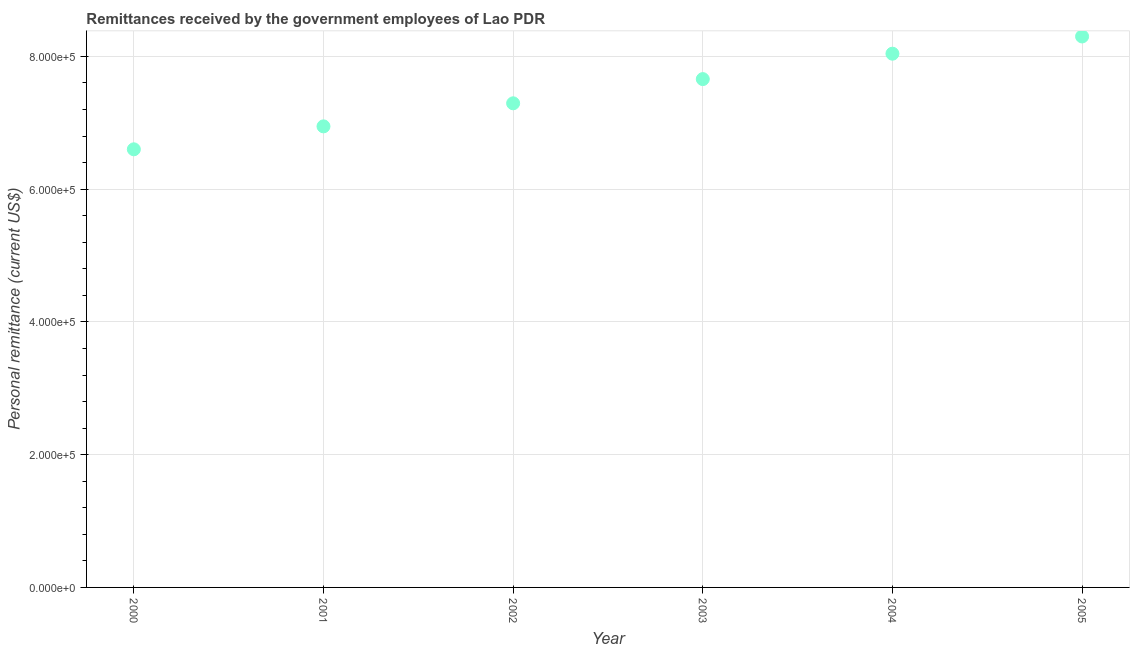What is the personal remittances in 2004?
Provide a succinct answer. 8.04e+05. Across all years, what is the maximum personal remittances?
Make the answer very short. 8.30e+05. Across all years, what is the minimum personal remittances?
Make the answer very short. 6.60e+05. In which year was the personal remittances maximum?
Your answer should be compact. 2005. What is the sum of the personal remittances?
Provide a succinct answer. 4.48e+06. What is the difference between the personal remittances in 2001 and 2003?
Your response must be concise. -7.12e+04. What is the average personal remittances per year?
Provide a short and direct response. 7.47e+05. What is the median personal remittances?
Make the answer very short. 7.48e+05. What is the ratio of the personal remittances in 2002 to that in 2005?
Your answer should be very brief. 0.88. Is the personal remittances in 2003 less than that in 2004?
Ensure brevity in your answer.  Yes. Is the difference between the personal remittances in 2001 and 2003 greater than the difference between any two years?
Provide a succinct answer. No. What is the difference between the highest and the second highest personal remittances?
Offer a very short reply. 2.59e+04. What is the difference between the highest and the lowest personal remittances?
Provide a succinct answer. 1.70e+05. In how many years, is the personal remittances greater than the average personal remittances taken over all years?
Provide a short and direct response. 3. Does the personal remittances monotonically increase over the years?
Your answer should be very brief. Yes. How many years are there in the graph?
Your response must be concise. 6. Are the values on the major ticks of Y-axis written in scientific E-notation?
Keep it short and to the point. Yes. Does the graph contain grids?
Your response must be concise. Yes. What is the title of the graph?
Your response must be concise. Remittances received by the government employees of Lao PDR. What is the label or title of the Y-axis?
Your response must be concise. Personal remittance (current US$). What is the Personal remittance (current US$) in 2000?
Provide a succinct answer. 6.60e+05. What is the Personal remittance (current US$) in 2001?
Give a very brief answer. 6.95e+05. What is the Personal remittance (current US$) in 2002?
Your answer should be very brief. 7.29e+05. What is the Personal remittance (current US$) in 2003?
Make the answer very short. 7.66e+05. What is the Personal remittance (current US$) in 2004?
Your answer should be very brief. 8.04e+05. What is the Personal remittance (current US$) in 2005?
Provide a succinct answer. 8.30e+05. What is the difference between the Personal remittance (current US$) in 2000 and 2001?
Provide a short and direct response. -3.46e+04. What is the difference between the Personal remittance (current US$) in 2000 and 2002?
Keep it short and to the point. -6.93e+04. What is the difference between the Personal remittance (current US$) in 2000 and 2003?
Give a very brief answer. -1.06e+05. What is the difference between the Personal remittance (current US$) in 2000 and 2004?
Your answer should be very brief. -1.44e+05. What is the difference between the Personal remittance (current US$) in 2000 and 2005?
Your response must be concise. -1.70e+05. What is the difference between the Personal remittance (current US$) in 2001 and 2002?
Provide a short and direct response. -3.47e+04. What is the difference between the Personal remittance (current US$) in 2001 and 2003?
Provide a short and direct response. -7.12e+04. What is the difference between the Personal remittance (current US$) in 2001 and 2004?
Offer a very short reply. -1.09e+05. What is the difference between the Personal remittance (current US$) in 2001 and 2005?
Ensure brevity in your answer.  -1.35e+05. What is the difference between the Personal remittance (current US$) in 2002 and 2003?
Your response must be concise. -3.65e+04. What is the difference between the Personal remittance (current US$) in 2002 and 2004?
Your answer should be compact. -7.48e+04. What is the difference between the Personal remittance (current US$) in 2002 and 2005?
Make the answer very short. -1.01e+05. What is the difference between the Personal remittance (current US$) in 2003 and 2004?
Your answer should be compact. -3.83e+04. What is the difference between the Personal remittance (current US$) in 2003 and 2005?
Provide a succinct answer. -6.42e+04. What is the difference between the Personal remittance (current US$) in 2004 and 2005?
Offer a terse response. -2.59e+04. What is the ratio of the Personal remittance (current US$) in 2000 to that in 2002?
Give a very brief answer. 0.91. What is the ratio of the Personal remittance (current US$) in 2000 to that in 2003?
Ensure brevity in your answer.  0.86. What is the ratio of the Personal remittance (current US$) in 2000 to that in 2004?
Ensure brevity in your answer.  0.82. What is the ratio of the Personal remittance (current US$) in 2000 to that in 2005?
Offer a very short reply. 0.8. What is the ratio of the Personal remittance (current US$) in 2001 to that in 2003?
Ensure brevity in your answer.  0.91. What is the ratio of the Personal remittance (current US$) in 2001 to that in 2004?
Offer a terse response. 0.86. What is the ratio of the Personal remittance (current US$) in 2001 to that in 2005?
Your answer should be very brief. 0.84. What is the ratio of the Personal remittance (current US$) in 2002 to that in 2003?
Keep it short and to the point. 0.95. What is the ratio of the Personal remittance (current US$) in 2002 to that in 2004?
Offer a very short reply. 0.91. What is the ratio of the Personal remittance (current US$) in 2002 to that in 2005?
Keep it short and to the point. 0.88. What is the ratio of the Personal remittance (current US$) in 2003 to that in 2005?
Your answer should be compact. 0.92. What is the ratio of the Personal remittance (current US$) in 2004 to that in 2005?
Give a very brief answer. 0.97. 